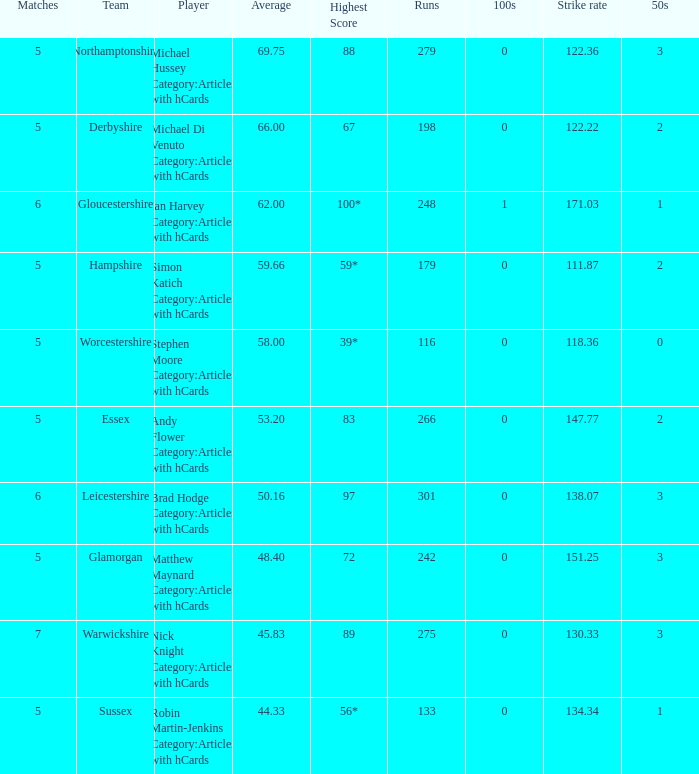If the average is 50.16, who is the player? Brad Hodge Category:Articles with hCards. Give me the full table as a dictionary. {'header': ['Matches', 'Team', 'Player', 'Average', 'Highest Score', 'Runs', '100s', 'Strike rate', '50s'], 'rows': [['5', 'Northamptonshire', 'Michael Hussey Category:Articles with hCards', '69.75', '88', '279', '0', '122.36', '3'], ['5', 'Derbyshire', 'Michael Di Venuto Category:Articles with hCards', '66.00', '67', '198', '0', '122.22', '2'], ['6', 'Gloucestershire', 'Ian Harvey Category:Articles with hCards', '62.00', '100*', '248', '1', '171.03', '1'], ['5', 'Hampshire', 'Simon Katich Category:Articles with hCards', '59.66', '59*', '179', '0', '111.87', '2'], ['5', 'Worcestershire', 'Stephen Moore Category:Articles with hCards', '58.00', '39*', '116', '0', '118.36', '0'], ['5', 'Essex', 'Andy Flower Category:Articles with hCards', '53.20', '83', '266', '0', '147.77', '2'], ['6', 'Leicestershire', 'Brad Hodge Category:Articles with hCards', '50.16', '97', '301', '0', '138.07', '3'], ['5', 'Glamorgan', 'Matthew Maynard Category:Articles with hCards', '48.40', '72', '242', '0', '151.25', '3'], ['7', 'Warwickshire', 'Nick Knight Category:Articles with hCards', '45.83', '89', '275', '0', '130.33', '3'], ['5', 'Sussex', 'Robin Martin-Jenkins Category:Articles with hCards', '44.33', '56*', '133', '0', '134.34', '1']]} 